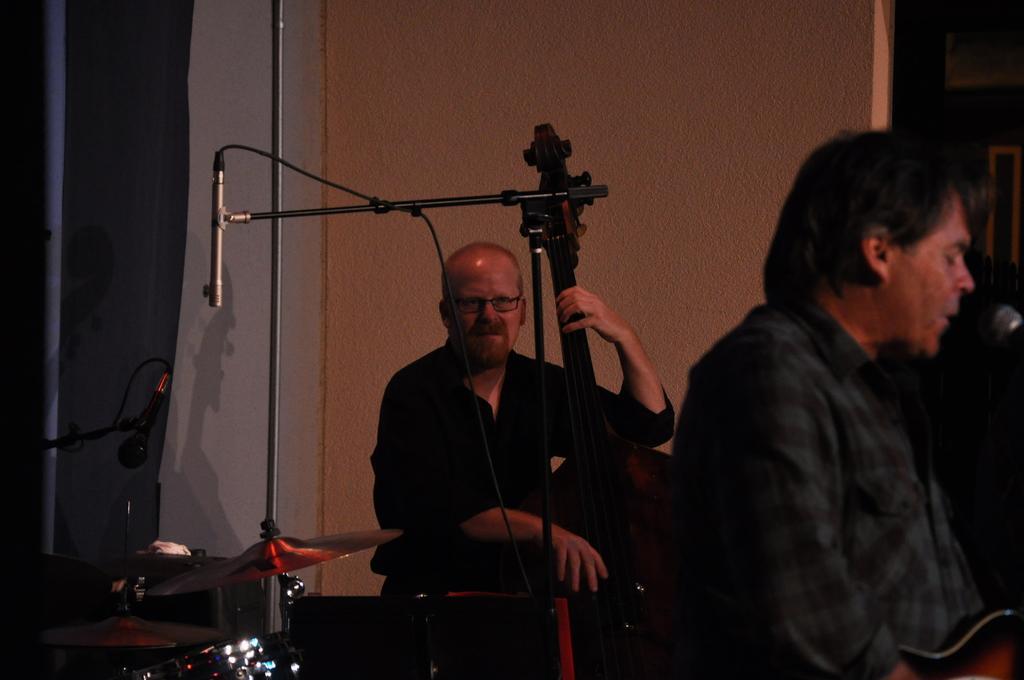Describe this image in one or two sentences. In this picture I can see two persons sitting and holding musical instruments, there are mike's, cymbals with the cymbals stands, and in the background there is a wall. 